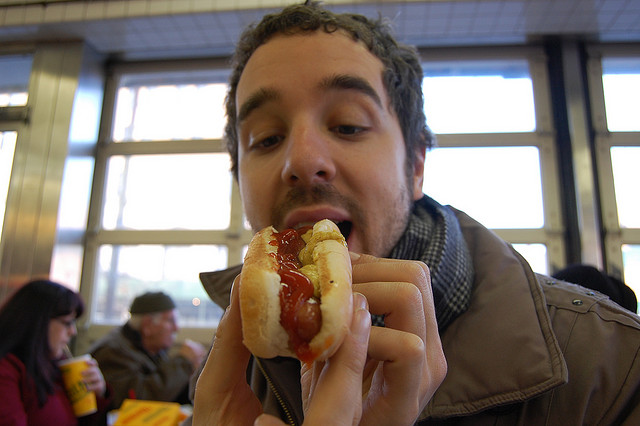How many zebras can you see? 0 